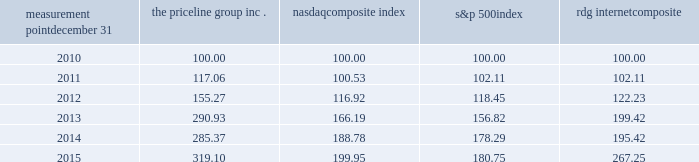Measurement point december 31 the priceline group nasdaq composite index s&p 500 rdg internet composite .

At the measurement point december 312015 what was ratio of the the priceline group inc.to the nasdaq composite index? 
Rationale: at the measurement point december 312015 the ratio of the the priceline group inc.to the nasdaq composite index was 1.6
Computations: (319.10 / 199.95)
Answer: 1.5959. Measurement point december 31 the priceline group nasdaq composite index s&p 500 rdg internet composite .

What was the difference in percentage change between the priceline group inc . and the s&p 500index for the five years ended 2015? 
Computations: (((319.10 - 100) / 100) - ((180.75 - 100) / 100))
Answer: 1.3835. 